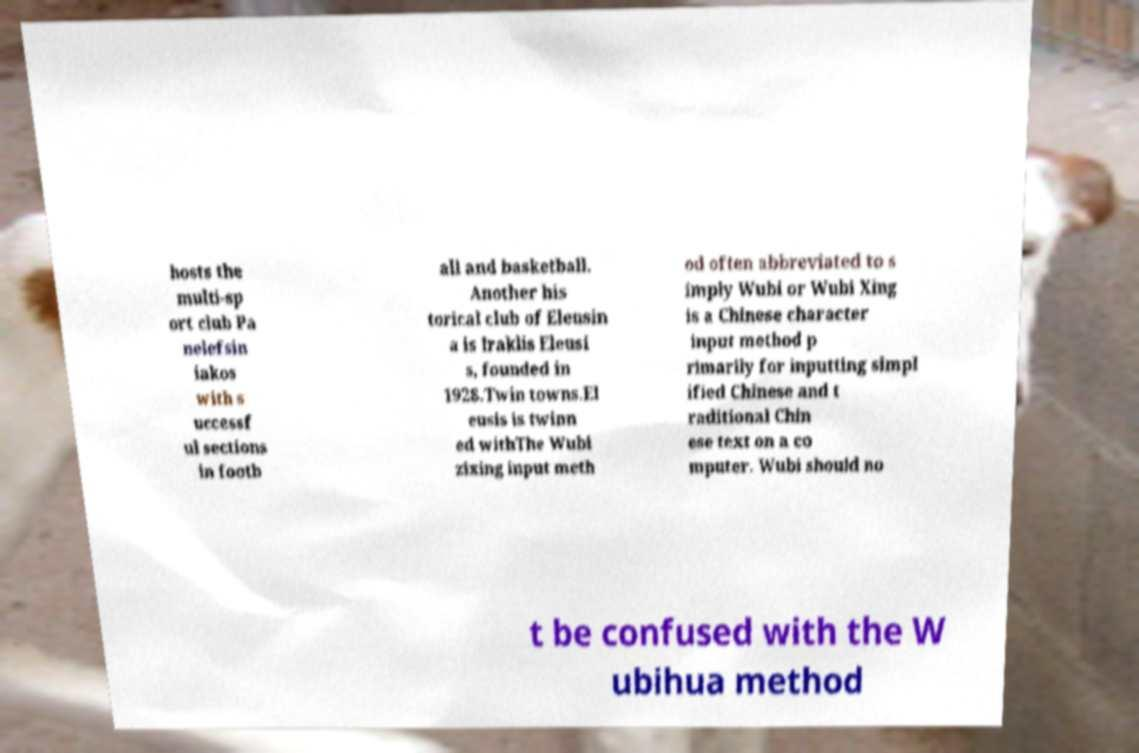Can you read and provide the text displayed in the image?This photo seems to have some interesting text. Can you extract and type it out for me? hosts the multi-sp ort club Pa nelefsin iakos with s uccessf ul sections in footb all and basketball. Another his torical club of Eleusin a is Iraklis Eleusi s, founded in 1928.Twin towns.El eusis is twinn ed withThe Wubi zixing input meth od often abbreviated to s imply Wubi or Wubi Xing is a Chinese character input method p rimarily for inputting simpl ified Chinese and t raditional Chin ese text on a co mputer. Wubi should no t be confused with the W ubihua method 